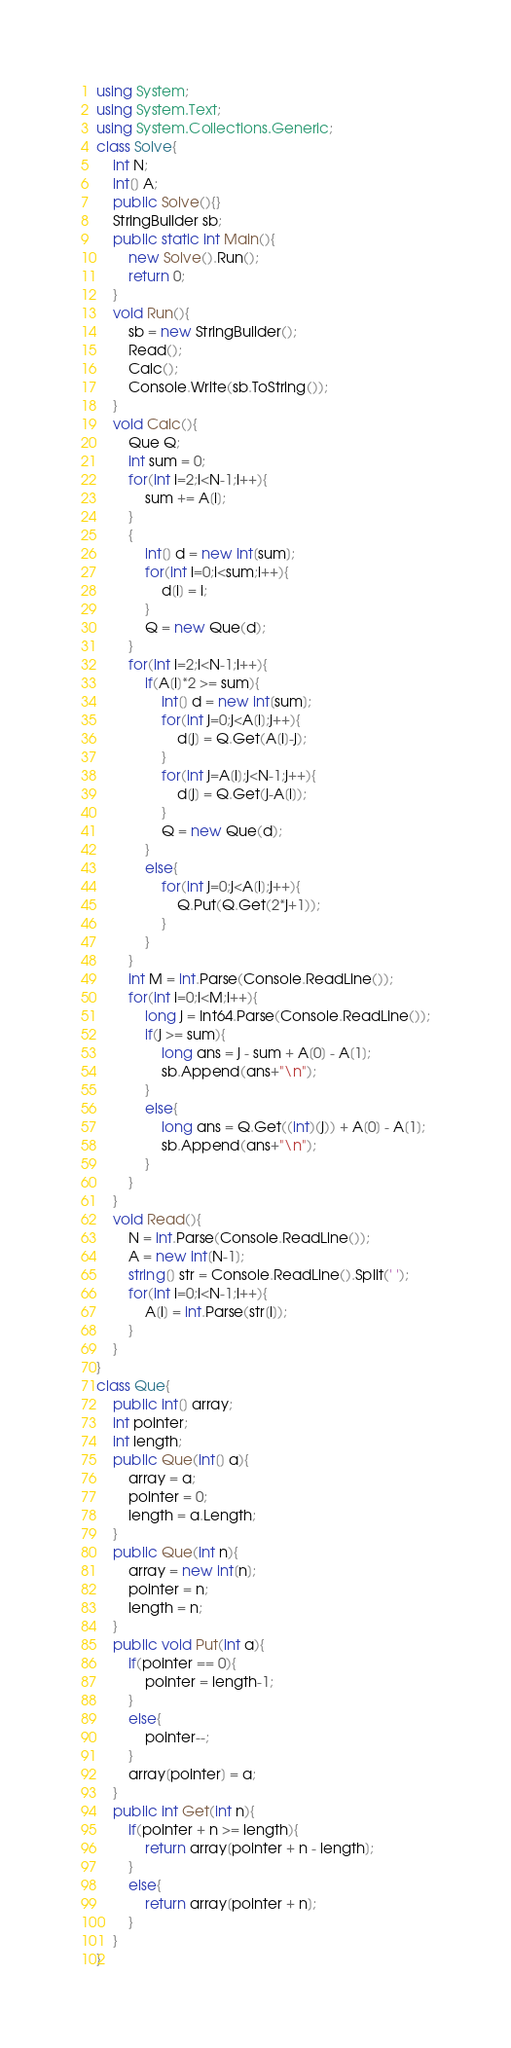Convert code to text. <code><loc_0><loc_0><loc_500><loc_500><_C#_>using System;
using System.Text;
using System.Collections.Generic;
class Solve{
    int N;
    int[] A;
    public Solve(){}
    StringBuilder sb;
    public static int Main(){
        new Solve().Run();
        return 0;
    }
    void Run(){
        sb = new StringBuilder();
        Read();
        Calc();
        Console.Write(sb.ToString());
    }
    void Calc(){
        Que Q;
        int sum = 0;
        for(int i=2;i<N-1;i++){
            sum += A[i];
        }
        {
            int[] d = new int[sum];
            for(int i=0;i<sum;i++){
                d[i] = i;
            }
            Q = new Que(d);
        }
        for(int i=2;i<N-1;i++){
            if(A[i]*2 >= sum){
                int[] d = new int[sum];
                for(int j=0;j<A[i];j++){
                    d[j] = Q.Get(A[i]-j);
                }
                for(int j=A[i];j<N-1;j++){
                    d[j] = Q.Get(j-A[i]);
                }
                Q = new Que(d);
            }
            else{
                for(int j=0;j<A[i];j++){
                    Q.Put(Q.Get(2*j+1));
                }
            }
        }
        int M = int.Parse(Console.ReadLine());
        for(int i=0;i<M;i++){
            long j = Int64.Parse(Console.ReadLine());
            if(j >= sum){
                long ans = j - sum + A[0] - A[1];
                sb.Append(ans+"\n");
            }
            else{
                long ans = Q.Get((int)(j)) + A[0] - A[1];
                sb.Append(ans+"\n");
            }
        }
    }
    void Read(){
        N = int.Parse(Console.ReadLine());
        A = new int[N-1];
        string[] str = Console.ReadLine().Split(' ');
        for(int i=0;i<N-1;i++){
            A[i] = int.Parse(str[i]);
        }
    }    
}
class Que{
    public int[] array;
    int pointer;
    int length;
    public Que(int[] a){
        array = a;
        pointer = 0;
        length = a.Length;
    }
    public Que(int n){
        array = new int[n];
        pointer = n;
        length = n;
    }
    public void Put(int a){
        if(pointer == 0){
            pointer = length-1;
        }
        else{
            pointer--;
        }
        array[pointer] = a;
    }
    public int Get(int n){
        if(pointer + n >= length){
            return array[pointer + n - length];
        }
        else{
            return array[pointer + n];
        }
    }
}</code> 